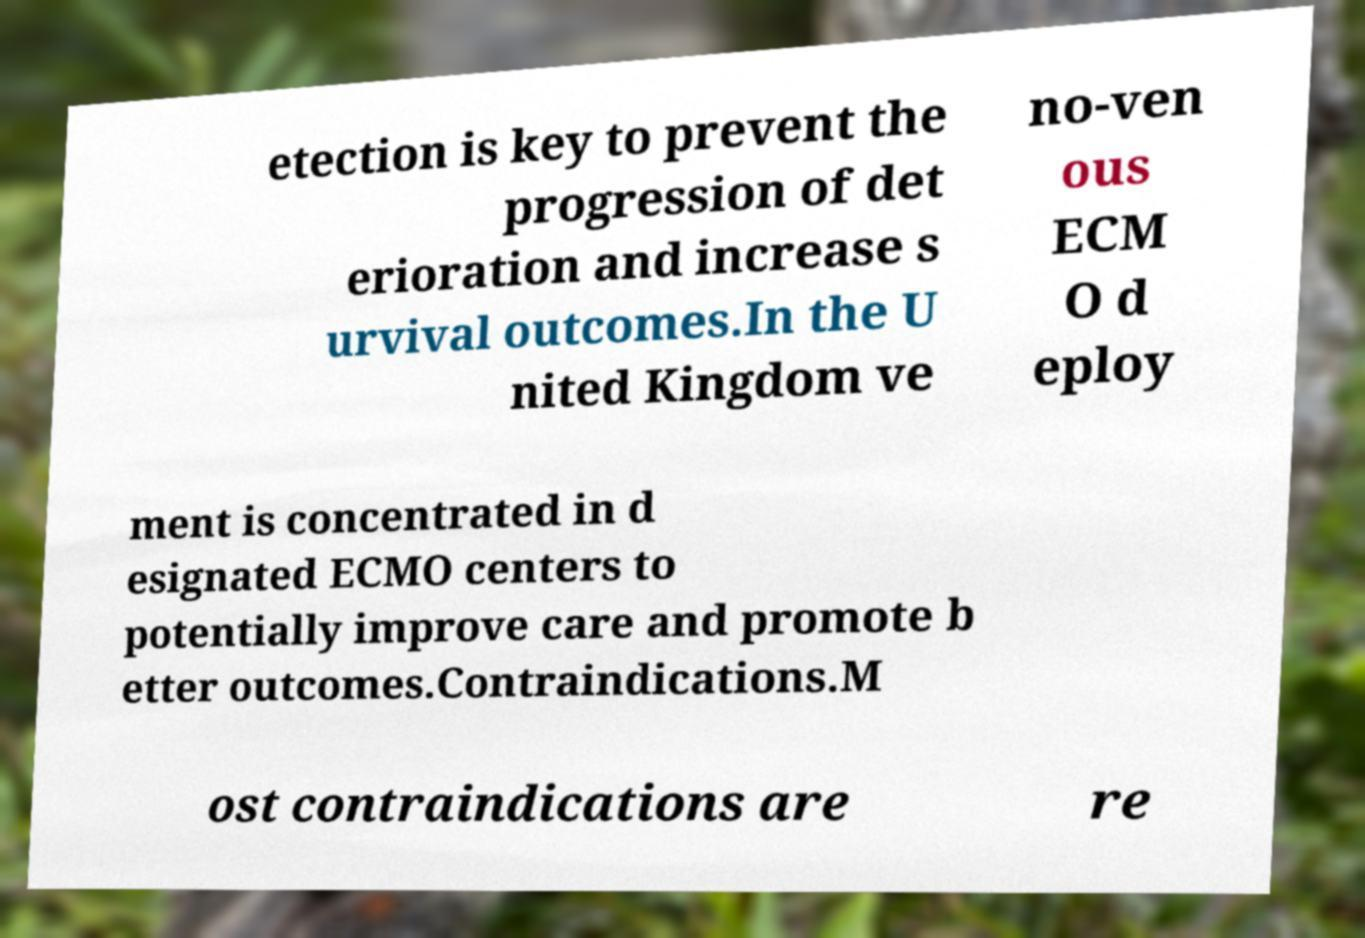Please read and relay the text visible in this image. What does it say? etection is key to prevent the progression of det erioration and increase s urvival outcomes.In the U nited Kingdom ve no-ven ous ECM O d eploy ment is concentrated in d esignated ECMO centers to potentially improve care and promote b etter outcomes.Contraindications.M ost contraindications are re 